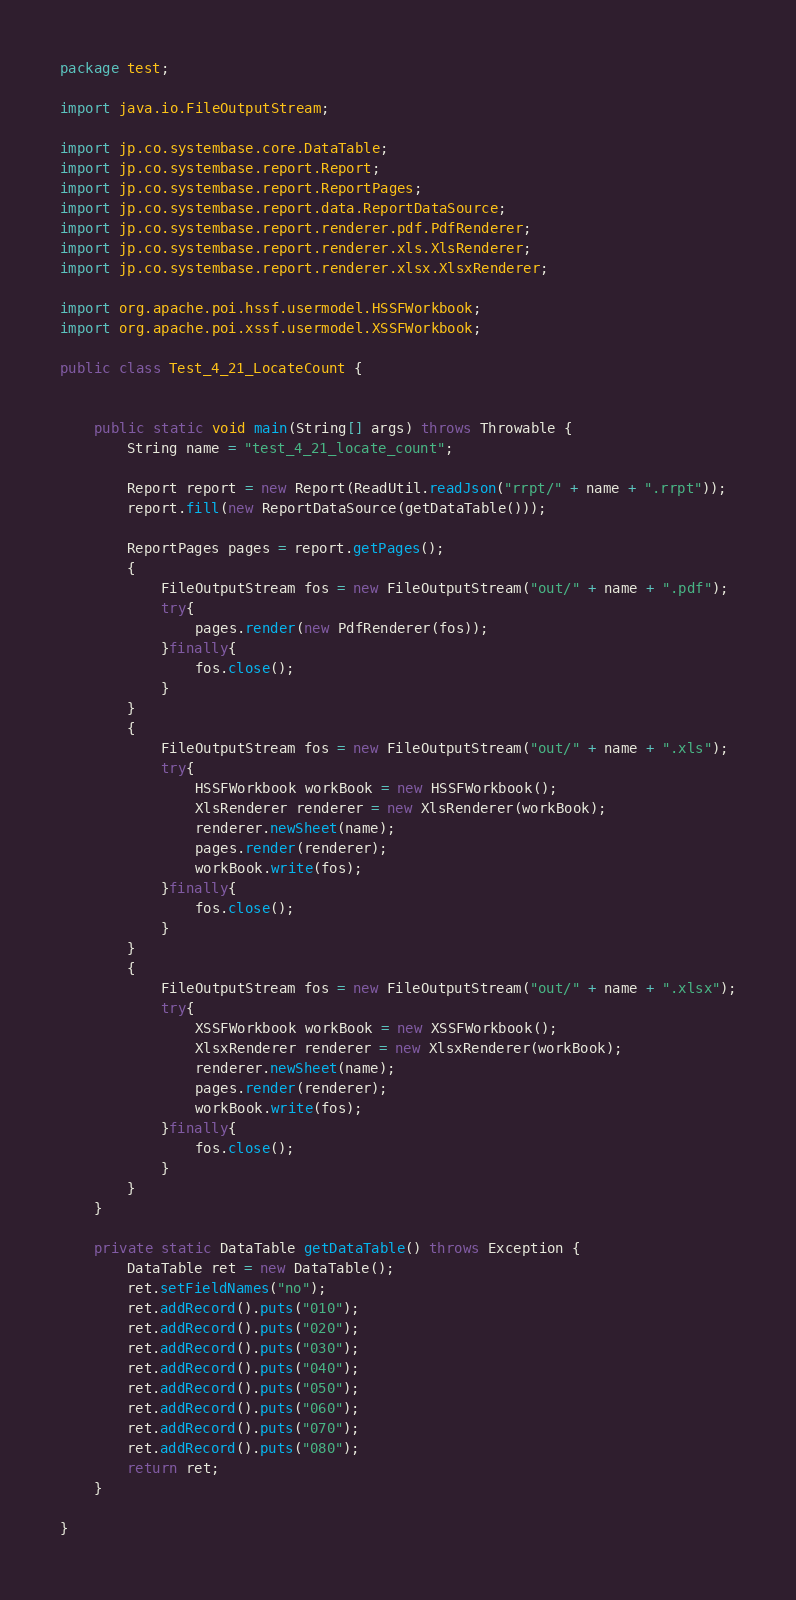Convert code to text. <code><loc_0><loc_0><loc_500><loc_500><_Java_>package test;

import java.io.FileOutputStream;

import jp.co.systembase.core.DataTable;
import jp.co.systembase.report.Report;
import jp.co.systembase.report.ReportPages;
import jp.co.systembase.report.data.ReportDataSource;
import jp.co.systembase.report.renderer.pdf.PdfRenderer;
import jp.co.systembase.report.renderer.xls.XlsRenderer;
import jp.co.systembase.report.renderer.xlsx.XlsxRenderer;

import org.apache.poi.hssf.usermodel.HSSFWorkbook;
import org.apache.poi.xssf.usermodel.XSSFWorkbook;

public class Test_4_21_LocateCount {


	public static void main(String[] args) throws Throwable {
		String name = "test_4_21_locate_count";
		
		Report report = new Report(ReadUtil.readJson("rrpt/" + name + ".rrpt"));
		report.fill(new ReportDataSource(getDataTable()));
		
		ReportPages pages = report.getPages();
		{
			FileOutputStream fos = new FileOutputStream("out/" + name + ".pdf");
			try{
				pages.render(new PdfRenderer(fos));
			}finally{
				fos.close();
			}
		}
		{
			FileOutputStream fos = new FileOutputStream("out/" + name + ".xls");
			try{
				HSSFWorkbook workBook = new HSSFWorkbook();
				XlsRenderer renderer = new XlsRenderer(workBook);
				renderer.newSheet(name);
				pages.render(renderer);
				workBook.write(fos);
			}finally{
				fos.close();
			}
		}
		{
			FileOutputStream fos = new FileOutputStream("out/" + name + ".xlsx");
			try{
				XSSFWorkbook workBook = new XSSFWorkbook();
				XlsxRenderer renderer = new XlsxRenderer(workBook);
				renderer.newSheet(name);
				pages.render(renderer);
				workBook.write(fos);
			}finally{
				fos.close();
			}
		}
	}
	
	private static DataTable getDataTable() throws Exception {
		DataTable ret = new DataTable();
		ret.setFieldNames("no");
		ret.addRecord().puts("010");
		ret.addRecord().puts("020");
		ret.addRecord().puts("030");
		ret.addRecord().puts("040");
		ret.addRecord().puts("050");
		ret.addRecord().puts("060");
		ret.addRecord().puts("070");
		ret.addRecord().puts("080");
		return ret;
	}

}
</code> 